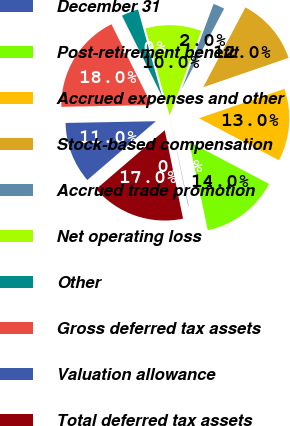<chart> <loc_0><loc_0><loc_500><loc_500><pie_chart><fcel>December 31<fcel>Post-retirement benefit<fcel>Accrued expenses and other<fcel>Stock-based compensation<fcel>Accrued trade promotion<fcel>Net operating loss<fcel>Other<fcel>Gross deferred tax assets<fcel>Valuation allowance<fcel>Total deferred tax assets<nl><fcel>0.06%<fcel>13.98%<fcel>12.98%<fcel>11.99%<fcel>2.04%<fcel>10.0%<fcel>3.04%<fcel>17.96%<fcel>10.99%<fcel>16.96%<nl></chart> 